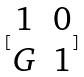<formula> <loc_0><loc_0><loc_500><loc_500>[ \begin{matrix} 1 & 0 \\ G & 1 \end{matrix} ]</formula> 